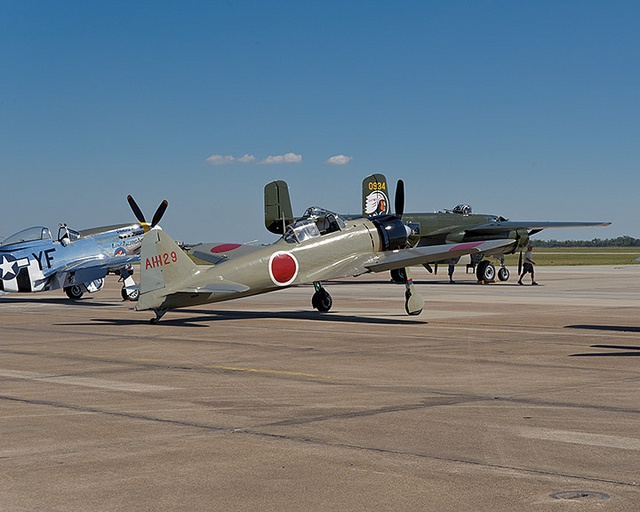Describe the objects in this image and their specific colors. I can see airplane in gray, black, and darkgray tones, airplane in gray, black, and lightgray tones, people in gray, black, and darkgray tones, and people in gray, black, and darkblue tones in this image. 